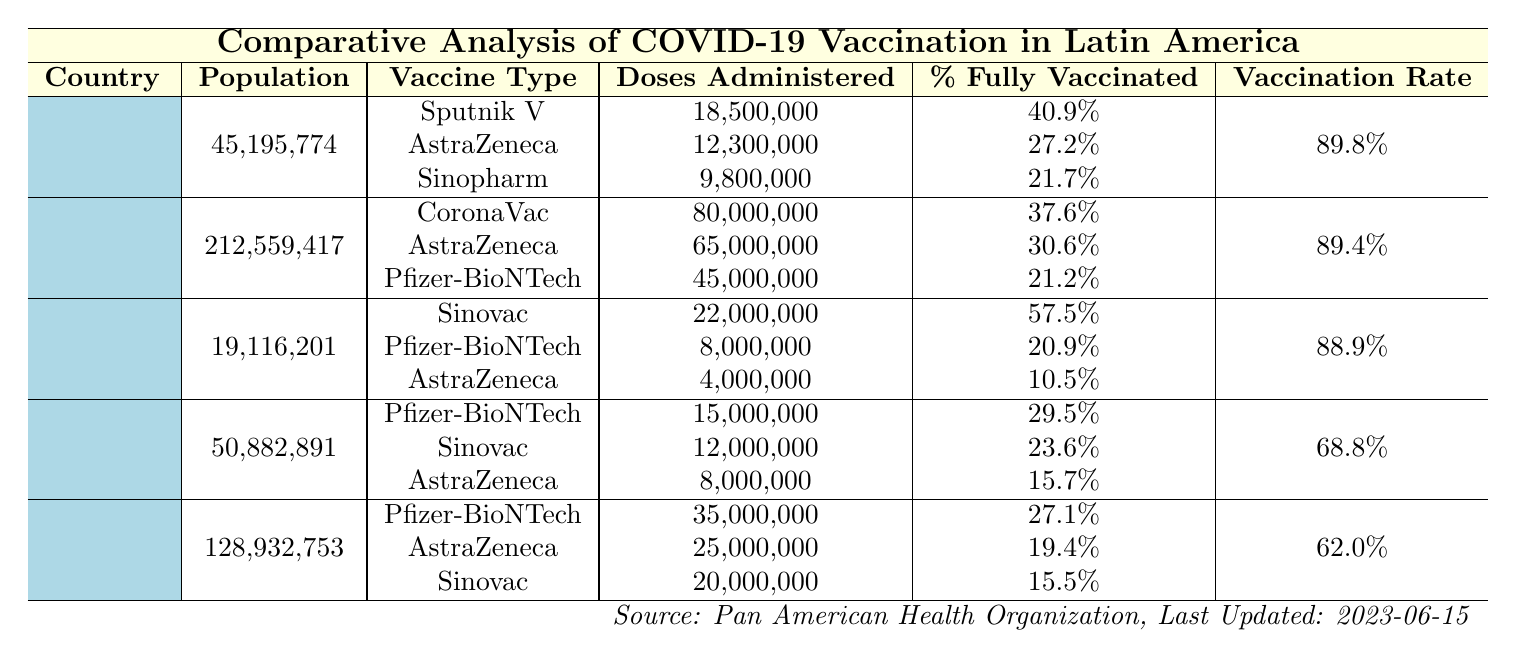What is the total population of Brazil? The table lists Brazil with a total population of 212,559,417.
Answer: 212,559,417 Which country has the highest percentage of fully vaccinated individuals? By examining the percentage fully vaccinated column, Chile, with 57.5%, has the highest percentage.
Answer: Chile How many doses of Pfizer-BioNTech were administered in Argentina? In Argentina, the table shows that 18,500,000 doses of Pfizer-BioNTech were administered.
Answer: 18,500,000 What is the vaccination rate per 100 individuals in Colombia? The table indicates that Colombia has a vaccination rate of 68.8% per 100 individuals.
Answer: 68.8% Which vaccine type had the lowest percentage of fully vaccinated individuals in Mexico? Upon reviewing the table, Sinovac has the lowest percentage of fully vaccinated individuals in Mexico, at 15.5%.
Answer: Sinovac What is the sum of doses administered for all vaccine types in Argentina? We sum the doses administered: 18,500,000 (Sputnik V) + 12,300,000 (AstraZeneca) + 9,800,000 (Sinopharm) = 40,600,000 total doses.
Answer: 40,600,000 If you combine the percentage of fully vaccinated individuals for AstraZeneca from all countries, what is the total? The combined percentage is: 27.2% (Argentina) + 30.6% (Brazil) + 10.5% (Chile) + 15.7% (Colombia) + 19.4% (Mexico) = 103.4%.
Answer: 103.4% Is Mexico's vaccination rate higher than that of Chile? By comparing the vaccination rates from the table, Mexico's rate is 62.0%, which is lower than Chile's 88.9%.
Answer: No Which country has administered the highest number of total doses, and what is that number? Brazil has administered the highest number of total doses at 80,000,000 doses of CoronaVac.
Answer: 80,000,000 What is the average percentage of fully vaccinated individuals across all countries? The average is calculated as follows: (40.9 + 37.6 + 57.5 + 29.5 + 27.1) / 5 = 38.12%, giving an average percentage of fully vaccinated individuals.
Answer: 38.12% 